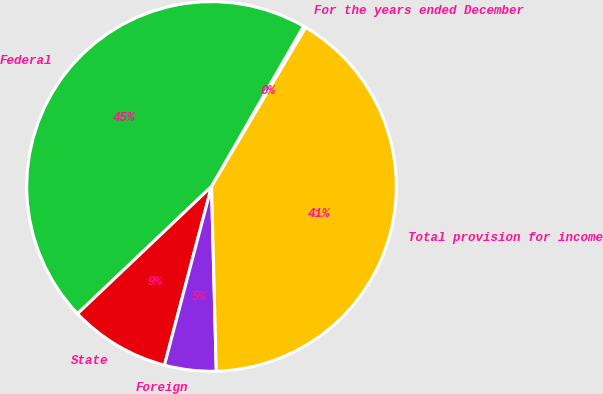<chart> <loc_0><loc_0><loc_500><loc_500><pie_chart><fcel>For the years ended December<fcel>Federal<fcel>State<fcel>Foreign<fcel>Total provision for income<nl><fcel>0.21%<fcel>45.38%<fcel>8.81%<fcel>4.51%<fcel>41.08%<nl></chart> 